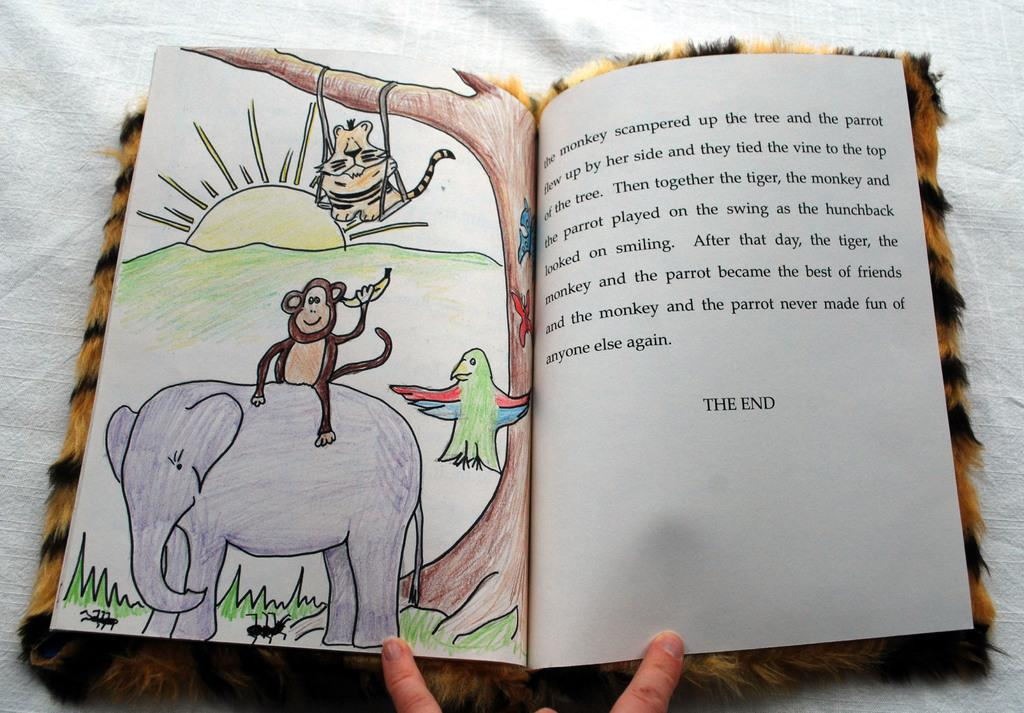What is the main object in the image? There is a book in the image. What is the color of the cloth in the image? The cloth in the image is white. What can be found on the book? The book has written matter on it, as well as drawings of an elephant, a monkey, a bird, and the sun. What type of ring is the secretary wearing in the image? There is no ring or secretary present in the image; it only features a book with drawings and written matter. 